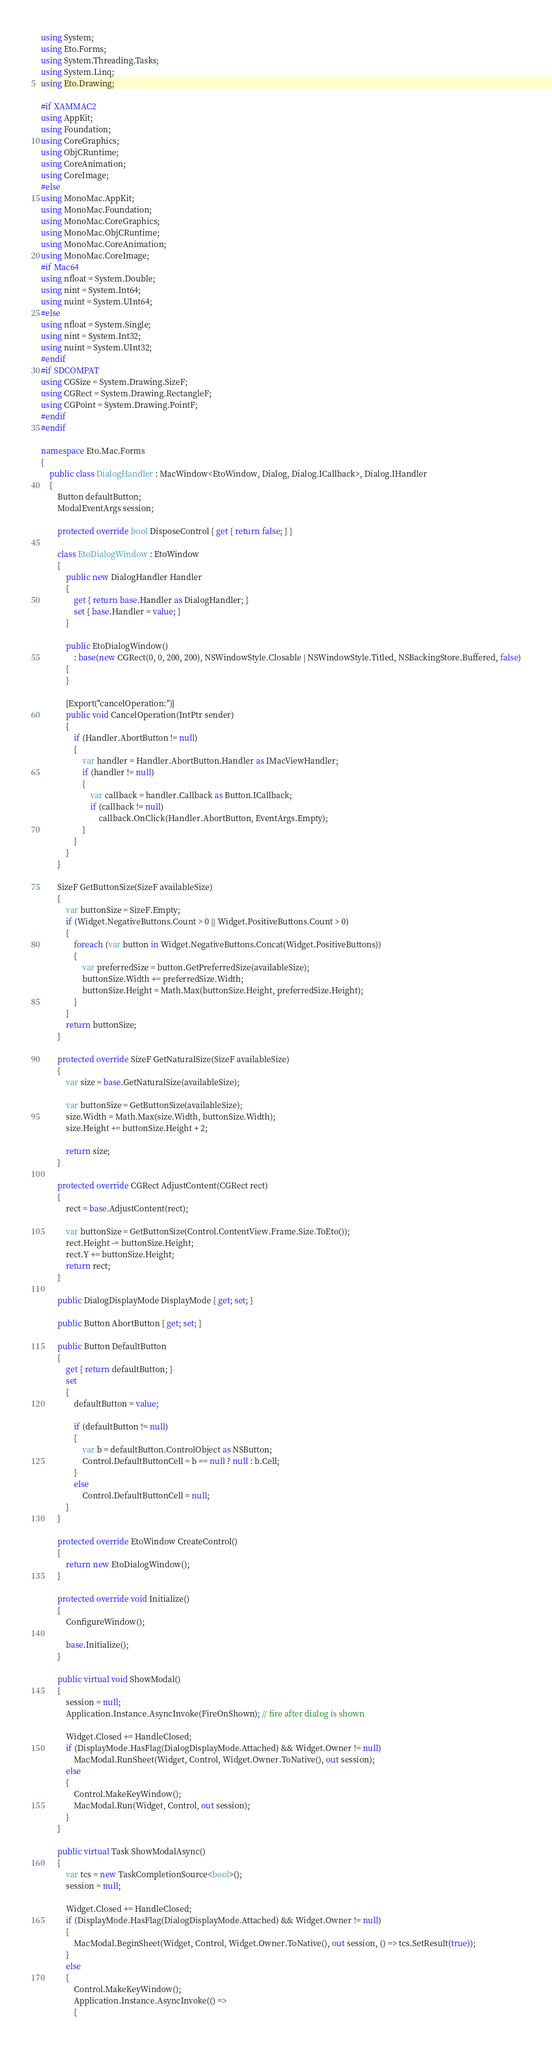<code> <loc_0><loc_0><loc_500><loc_500><_C#_>using System;
using Eto.Forms;
using System.Threading.Tasks;
using System.Linq;
using Eto.Drawing;

#if XAMMAC2
using AppKit;
using Foundation;
using CoreGraphics;
using ObjCRuntime;
using CoreAnimation;
using CoreImage;
#else
using MonoMac.AppKit;
using MonoMac.Foundation;
using MonoMac.CoreGraphics;
using MonoMac.ObjCRuntime;
using MonoMac.CoreAnimation;
using MonoMac.CoreImage;
#if Mac64
using nfloat = System.Double;
using nint = System.Int64;
using nuint = System.UInt64;
#else
using nfloat = System.Single;
using nint = System.Int32;
using nuint = System.UInt32;
#endif
#if SDCOMPAT
using CGSize = System.Drawing.SizeF;
using CGRect = System.Drawing.RectangleF;
using CGPoint = System.Drawing.PointF;
#endif
#endif

namespace Eto.Mac.Forms
{
	public class DialogHandler : MacWindow<EtoWindow, Dialog, Dialog.ICallback>, Dialog.IHandler
	{
		Button defaultButton;
		ModalEventArgs session;

		protected override bool DisposeControl { get { return false; } }

		class EtoDialogWindow : EtoWindow
		{
			public new DialogHandler Handler
			{
				get { return base.Handler as DialogHandler; }
				set { base.Handler = value; }
			}

			public EtoDialogWindow()
				: base(new CGRect(0, 0, 200, 200), NSWindowStyle.Closable | NSWindowStyle.Titled, NSBackingStore.Buffered, false)
			{
			}

			[Export("cancelOperation:")]
			public void CancelOperation(IntPtr sender)
			{
				if (Handler.AbortButton != null)
				{
					var handler = Handler.AbortButton.Handler as IMacViewHandler;
					if (handler != null)
					{
						var callback = handler.Callback as Button.ICallback;
						if (callback != null)
							callback.OnClick(Handler.AbortButton, EventArgs.Empty);
					}
				}
			}
		}

		SizeF GetButtonSize(SizeF availableSize)
		{
			var buttonSize = SizeF.Empty;
			if (Widget.NegativeButtons.Count > 0 || Widget.PositiveButtons.Count > 0)
			{
				foreach (var button in Widget.NegativeButtons.Concat(Widget.PositiveButtons))
				{
					var preferredSize = button.GetPreferredSize(availableSize);
					buttonSize.Width += preferredSize.Width;
					buttonSize.Height = Math.Max(buttonSize.Height, preferredSize.Height);
				}
			}
			return buttonSize;
		}

		protected override SizeF GetNaturalSize(SizeF availableSize)
		{
			var size = base.GetNaturalSize(availableSize);

			var buttonSize = GetButtonSize(availableSize);
			size.Width = Math.Max(size.Width, buttonSize.Width);
			size.Height += buttonSize.Height + 2;

			return size;
		}

		protected override CGRect AdjustContent(CGRect rect)
		{
			rect = base.AdjustContent(rect);

			var buttonSize = GetButtonSize(Control.ContentView.Frame.Size.ToEto());
			rect.Height -= buttonSize.Height;
			rect.Y += buttonSize.Height;
			return rect;
		}

		public DialogDisplayMode DisplayMode { get; set; }

		public Button AbortButton { get; set; }

		public Button DefaultButton
		{
			get { return defaultButton; }
			set
			{
				defaultButton = value;
				
				if (defaultButton != null)
				{
					var b = defaultButton.ControlObject as NSButton;
					Control.DefaultButtonCell = b == null ? null : b.Cell;
				}
				else
					Control.DefaultButtonCell = null;
			}
		}

		protected override EtoWindow CreateControl()
		{
			return new EtoDialogWindow();
		}

		protected override void Initialize()
		{
			ConfigureWindow();

			base.Initialize();
		}

		public virtual void ShowModal()
		{
			session = null;
			Application.Instance.AsyncInvoke(FireOnShown); // fire after dialog is shown

			Widget.Closed += HandleClosed;
			if (DisplayMode.HasFlag(DialogDisplayMode.Attached) && Widget.Owner != null)
				MacModal.RunSheet(Widget, Control, Widget.Owner.ToNative(), out session);
			else
			{
				Control.MakeKeyWindow();
				MacModal.Run(Widget, Control, out session);
			}
		}

		public virtual Task ShowModalAsync()
		{
			var tcs = new TaskCompletionSource<bool>();
			session = null;

			Widget.Closed += HandleClosed;
			if (DisplayMode.HasFlag(DialogDisplayMode.Attached) && Widget.Owner != null)
			{
				MacModal.BeginSheet(Widget, Control, Widget.Owner.ToNative(), out session, () => tcs.SetResult(true));
			}
			else
			{
				Control.MakeKeyWindow();
				Application.Instance.AsyncInvoke(() =>
				{</code> 